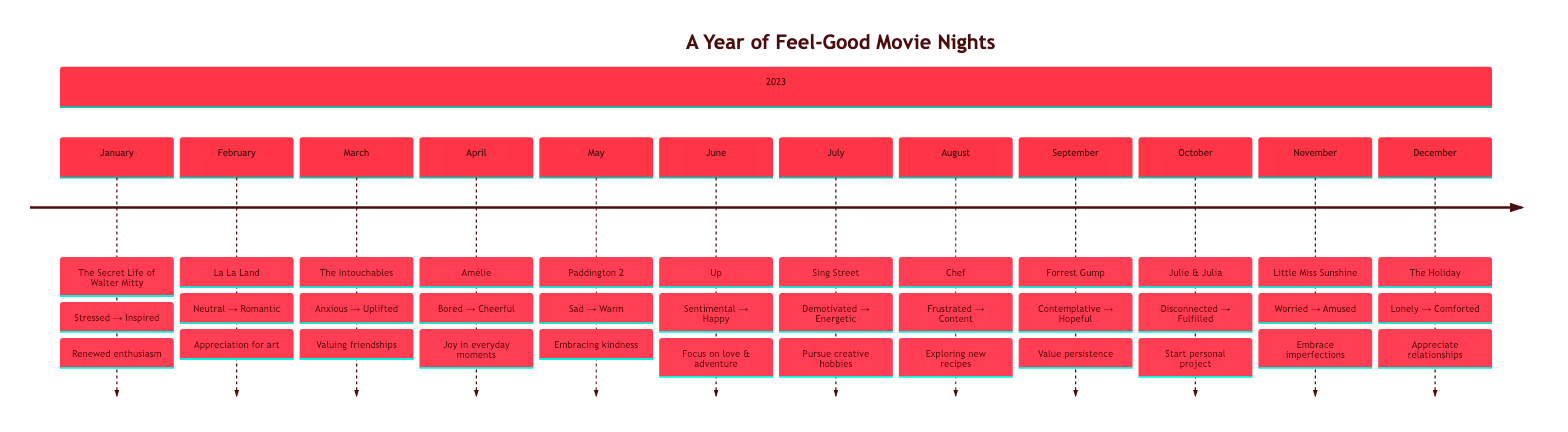What movie was watched in February 2023? The event for February 2023 displays "La La Land" as the movie watched that month.
Answer: La La Land What was the mood before watching "The Intouchables"? The information for March indicates the mood before watching "The Intouchables" was "Anxious".
Answer: Anxious How many movies were watched in total? By counting each entry in the timeline, there are a total of 12 movies listed throughout the year.
Answer: 12 What was the mood after watching "Up"? The June entry shows the mood after watching "Up" was "Happy and emotionally fulfilled".
Answer: Happy and emotionally fulfilled Which movie resulted in a feeling of "Relieved and amused"? In the November section, it shows that after watching "Little Miss Sunshine," the mood was "Relieved and amused."
Answer: Little Miss Sunshine What was the impact on daily life after watching "Chef"? The impact recorded after watching "Chef" was "Interest in exploring new recipes and cooking."
Answer: Interest in exploring new recipes and cooking Which month featured a movie that increased the viewer's appreciation for artistic expression? The February entry indicates that watching "La La Land" led to an increased appreciation for artistic expression.
Answer: February What overall change in mood did viewers experience after watching movies in this timeline? Generally, viewers moved from various negative or neutral moods to positive moods like "Inspired," "Joyful," and "Comforted" after each movie.
Answer: Positive moods 